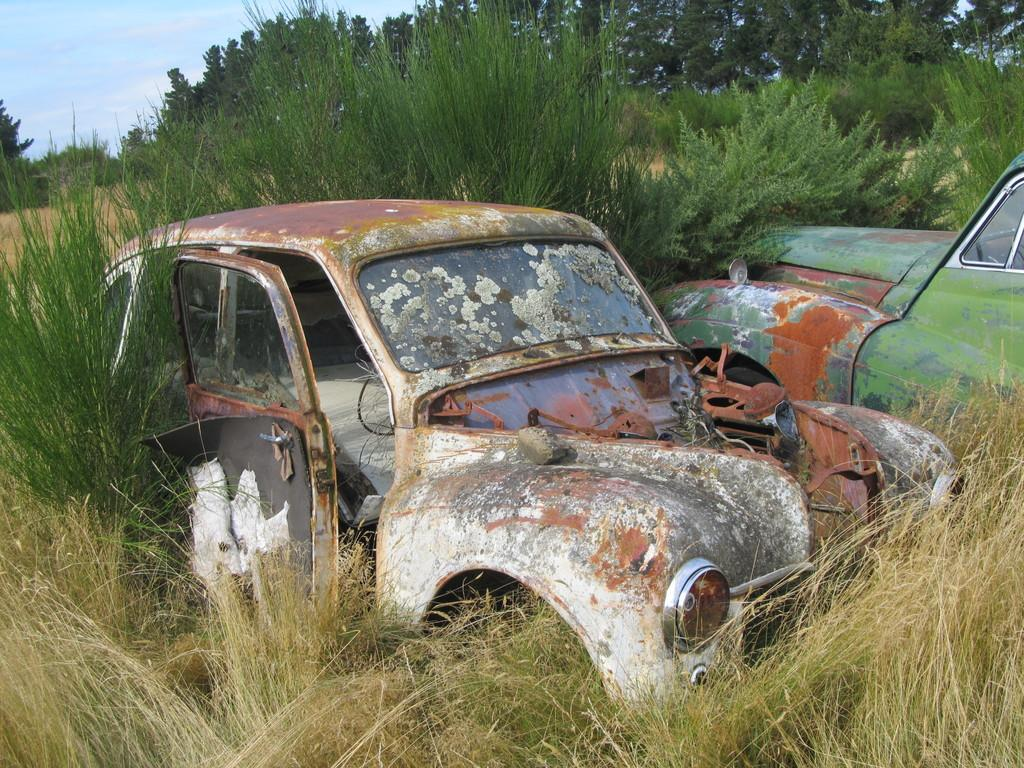What type of vehicles are in the image? There are old vehicles in the image. Where are the vehicles located? The vehicles are on the grass. What can be seen in the background of the image? There are trees and the sky visible in the background of the image. What type of berry is growing on the dirt in the image? There is no dirt or berry present in the image. 